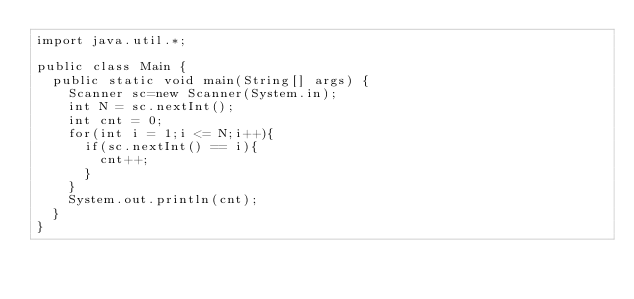Convert code to text. <code><loc_0><loc_0><loc_500><loc_500><_Java_>import java.util.*;

public class Main {
  public static void main(String[] args) {
    Scanner sc=new Scanner(System.in);
    int N = sc.nextInt();
    int cnt = 0;
    for(int i = 1;i <= N;i++){
      if(sc.nextInt() == i){
        cnt++;
      }
    }
    System.out.println(cnt);
  }
}
        
</code> 